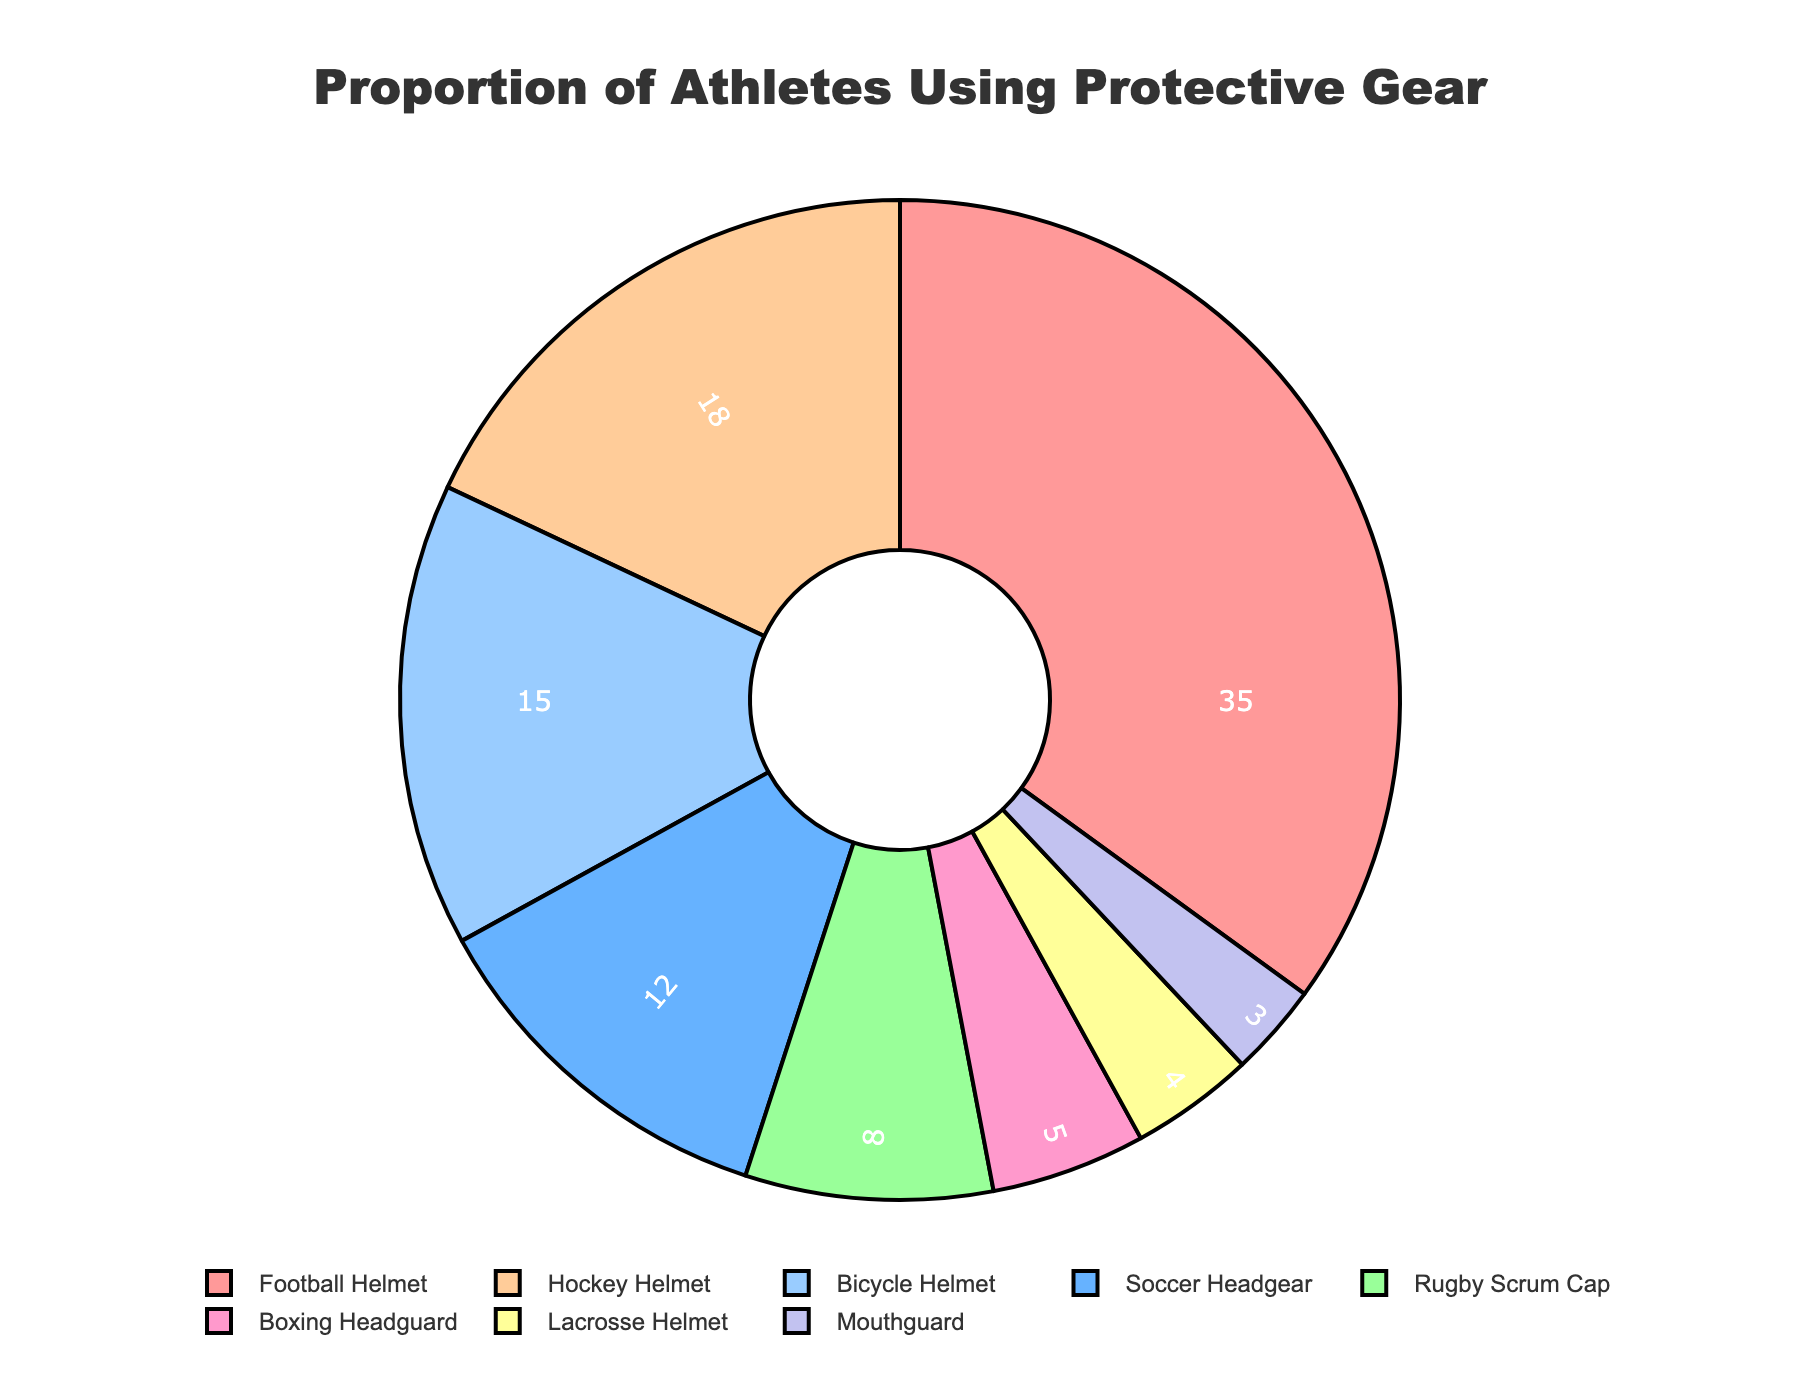What type of protective gear is the most commonly used according to the pie chart? The pie chart shows that the segment with the largest proportion represents "Football Helmet" at 35%. Therefore, Football Helmet is the most commonly used protective gear.
Answer: Football Helmet What protective gear has the second-highest usage among athletes? The second-largest segment in the pie chart is "Hockey Helmet" with 18%. Thus, Hockey Helmet has the second-highest usage.
Answer: Hockey Helmet How does the usage of Football Helmet compare to Soccer Headgear? By looking at the pie chart, the Football Helmet usage is 35%, and the Soccer Headgear usage is 12%. Football Helmet usage is substantially higher than Soccer Headgear.
Answer: Football Helmet usage is higher What is the combined percentage of athletes using either a Rugby Scrum Cap or Lacrosse Helmet? Rugby Scrum Cap and Lacrosse Helmet have percentages of 8% and 4%, respectively. Adding these together gives 8% + 4% = 12%.
Answer: 12% Which protective gear is used the least according to the pie chart? The smallest segment in the pie chart corresponds to "Mouthguard" with a usage of 3%. Therefore, Mouthguard is the least used protective gear.
Answer: Mouthguard How much more frequently is a Bicycle Helmet used compared to a Boxing Headguard? The pie chart shows that Bicycle Helmet usage is 15%, and Boxing Headguard usage is 5%. The difference is 15% - 5% = 10%.
Answer: 10% What is the average usage percentage of Hockey Helmet, Bicycle Helmet, and Boxing Headguard? The usage percentages are 18% for Hockey Helmet, 15% for Bicycle Helmet, and 5% for Boxing Headguard. Adding these gives 18% + 15% + 5% = 38%. Dividing by 3 gives 38% / 3 ≈ 12.67%.
Answer: 12.67% Are there more athletes using a Football Helmet or the combined total of those using a Soccer Headgear and a Hockey Helmet? Football Helmet usage is 35%, while the combined total for Soccer Headgear (12%) and Hockey Helmet (18%) is 12% + 18% = 30%. Therefore, Football Helmet usage is greater.
Answer: Football Helmet usage is greater 